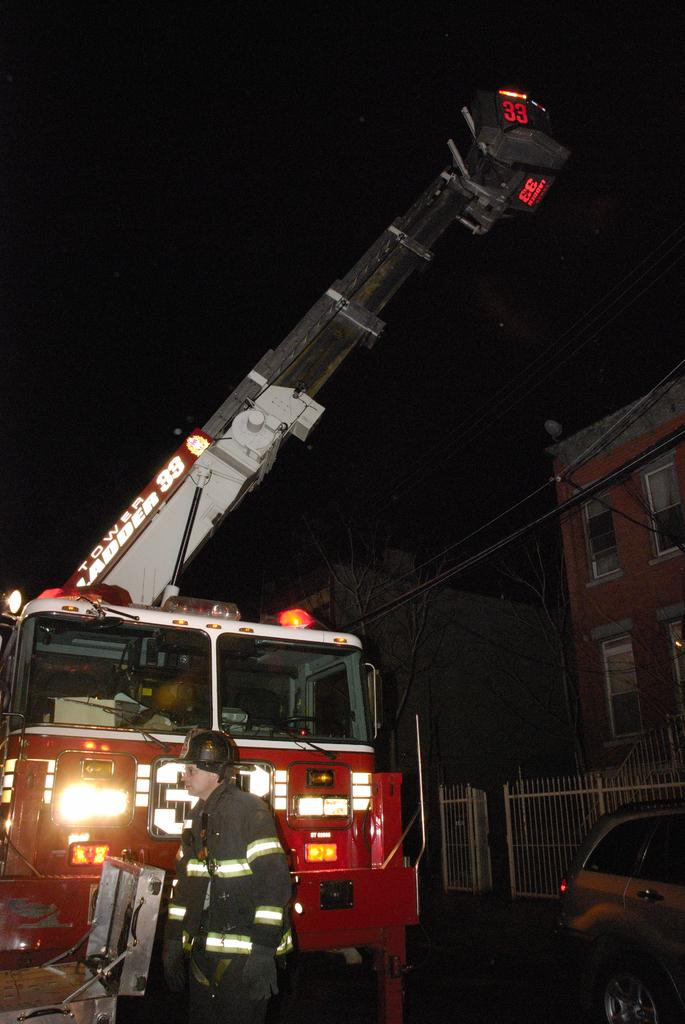What is the main subject of the image? There is a person standing in the image. What is located behind the person? There is a fire engine behind the person. What other vehicle can be seen in the image? There is a car on the right side of the image. What can be seen in the distance in the image? There are two buildings and trees visible in the background of the image. Where is the boat located in the image? There is no boat present in the image. What type of shelf can be seen on the left side of the image? There is no shelf present in the image. 